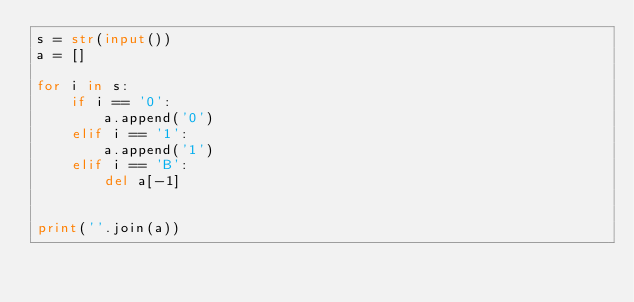<code> <loc_0><loc_0><loc_500><loc_500><_Python_>s = str(input())
a = []

for i in s:
    if i == '0':
        a.append('0') 
    elif i == '1':
        a.append('1')
    elif i == 'B':
        del a[-1]
        

print(''.join(a))</code> 